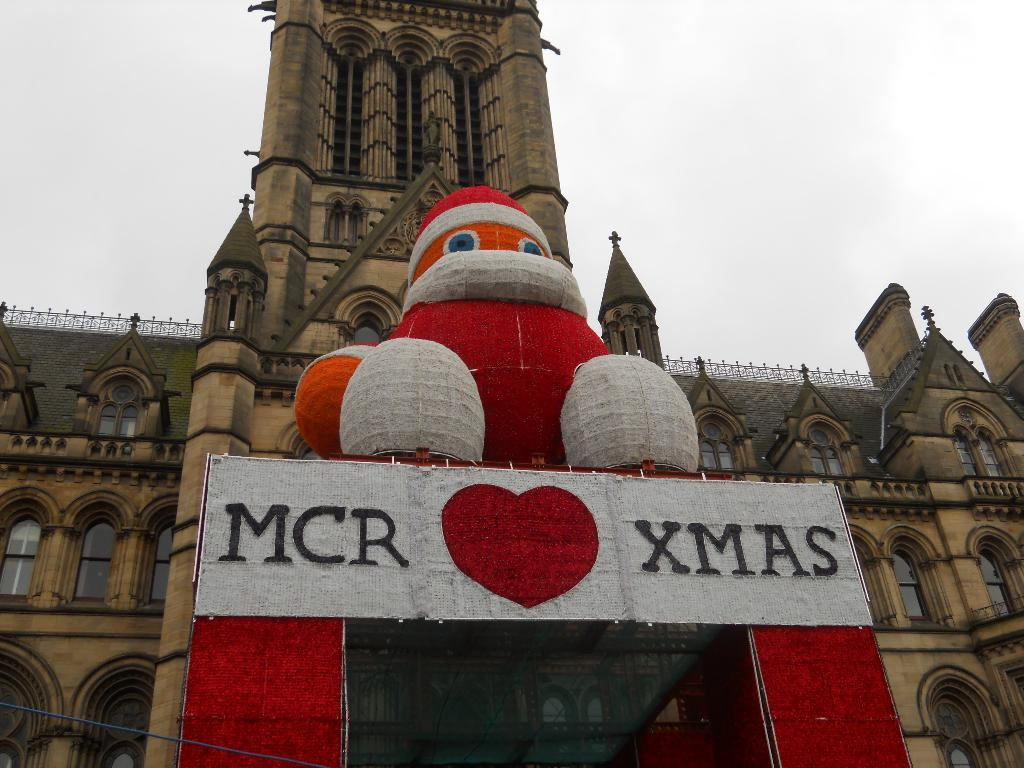What type of decoration can be seen in the image? There is a Christmas decoration in the image. What colors are used for the Christmas decoration? The Christmas decoration is in red and white colors. Where is the Christmas decoration located in relation to the castle? The Christmas decoration is in front of a castle. What can be seen in the background of the image? The sky is visible in the background of the image. How many ants are crawling on the Christmas decoration in the image? There are no ants present in the image; it only features a Christmas decoration in front of a castle. 